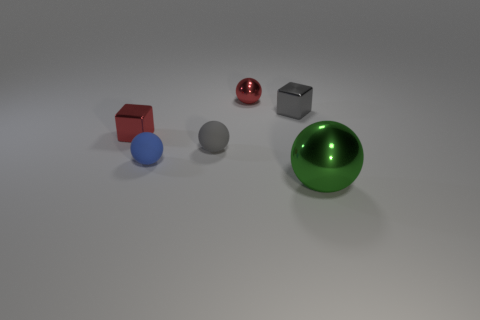Add 4 small yellow metallic cubes. How many objects exist? 10 Subtract all tiny balls. How many balls are left? 1 Subtract all red cubes. How many cubes are left? 1 Subtract 3 balls. How many balls are left? 1 Subtract all green cubes. Subtract all red cylinders. How many cubes are left? 2 Subtract all yellow cubes. How many purple balls are left? 0 Subtract all yellow cylinders. Subtract all large green things. How many objects are left? 5 Add 2 small red cubes. How many small red cubes are left? 3 Add 6 blue spheres. How many blue spheres exist? 7 Subtract 1 gray blocks. How many objects are left? 5 